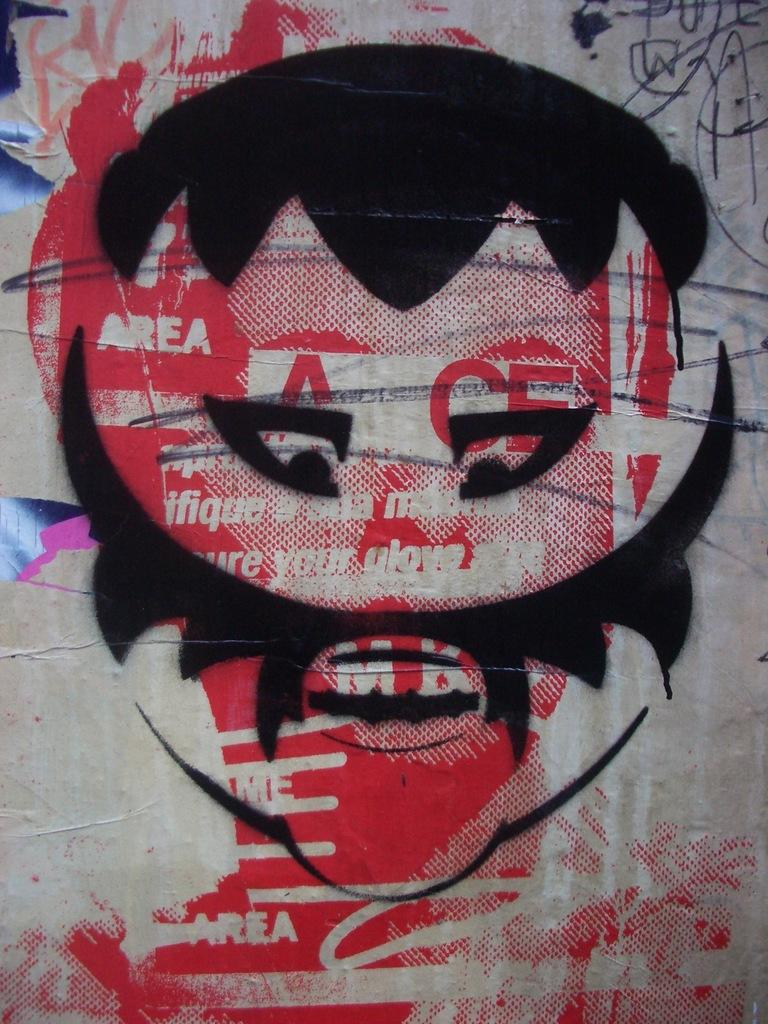What is the main subject of the painting in the image? The main subject of the painting in the image is a man. What are some of the features of the man in the painting? The man in the painting has hair, eyes, and a mustache. Can you see any spots on the man's growth in the painting? There is no mention of spots or growth in the provided facts about the painting. The facts only mention the man's hair, eyes, and mustache. Are there any clouds visible in the painting? There is no mention of clouds in the provided facts about the painting. The facts only mention the man's hair, eyes, and mustache. 